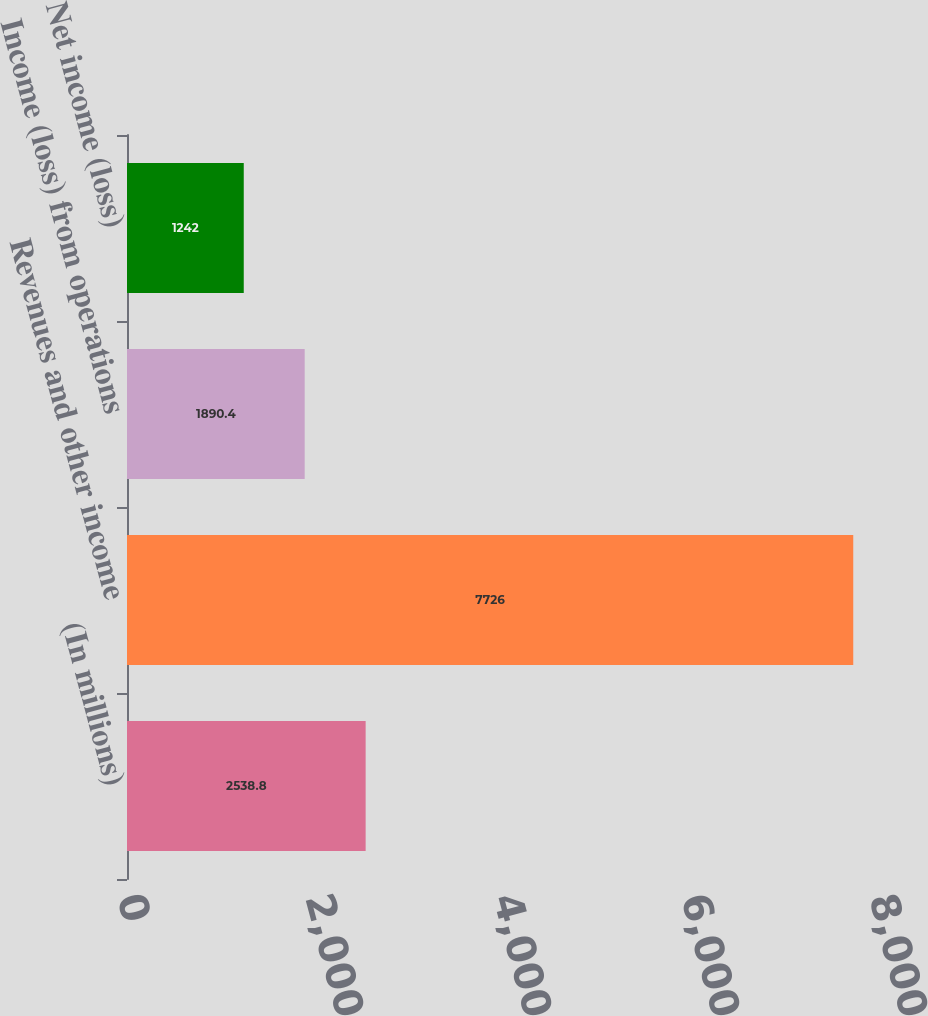Convert chart to OTSL. <chart><loc_0><loc_0><loc_500><loc_500><bar_chart><fcel>(In millions)<fcel>Revenues and other income<fcel>Income (loss) from operations<fcel>Net income (loss)<nl><fcel>2538.8<fcel>7726<fcel>1890.4<fcel>1242<nl></chart> 